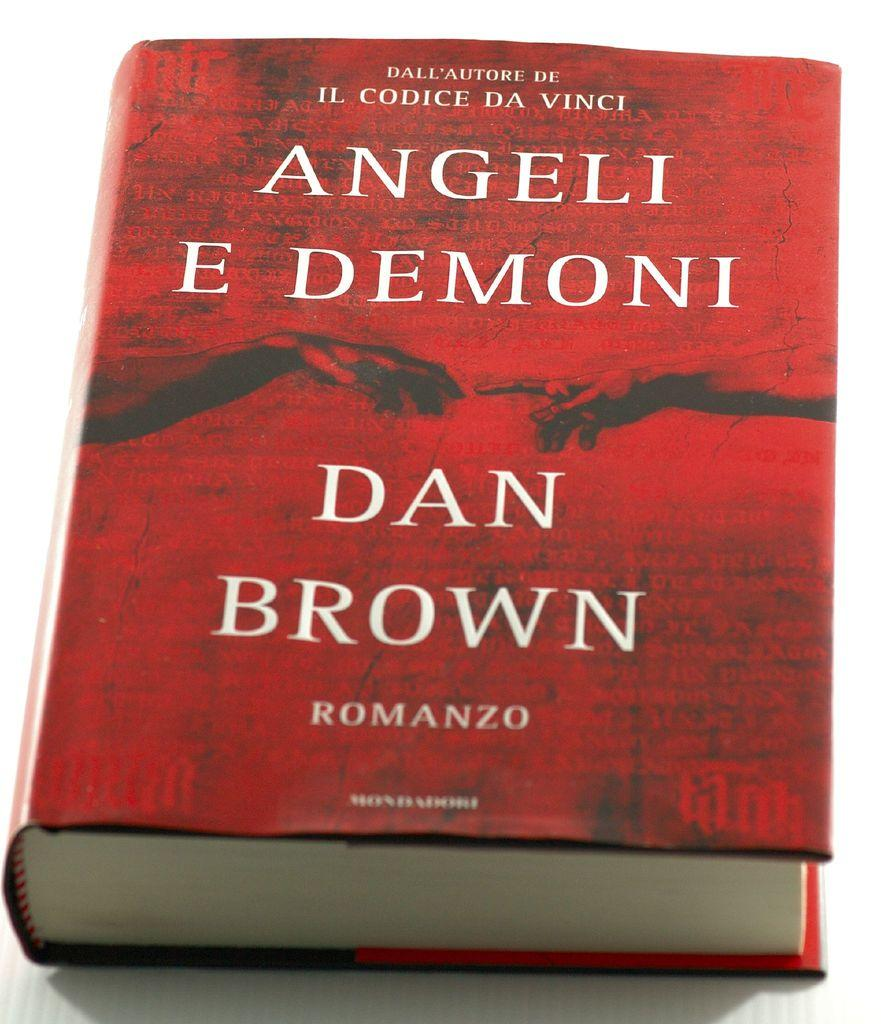<image>
Create a compact narrative representing the image presented. A hardcover red book written by Dan Brown. 